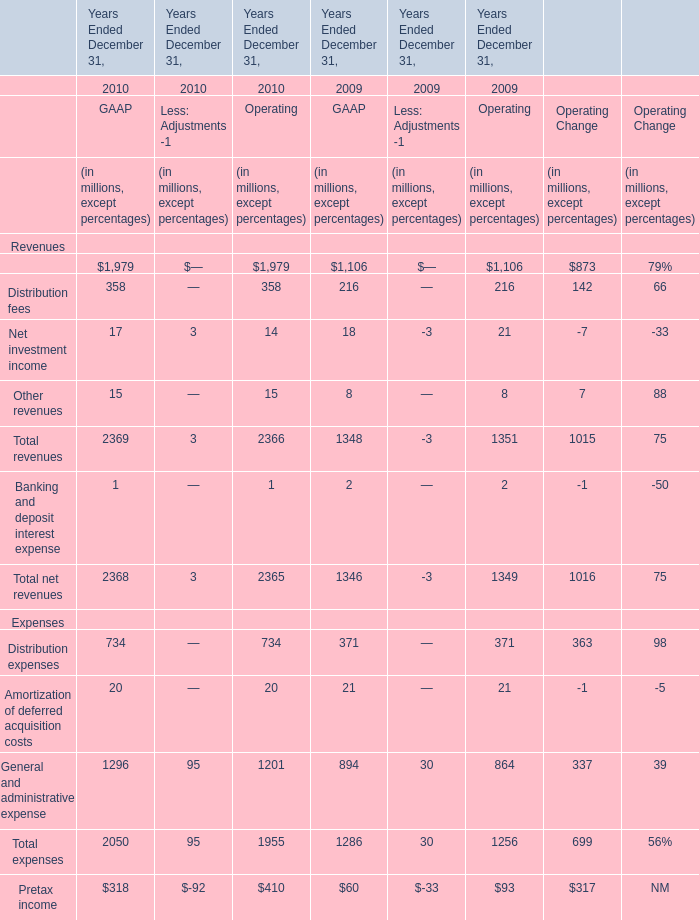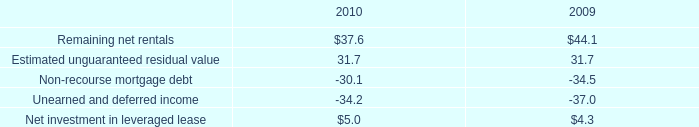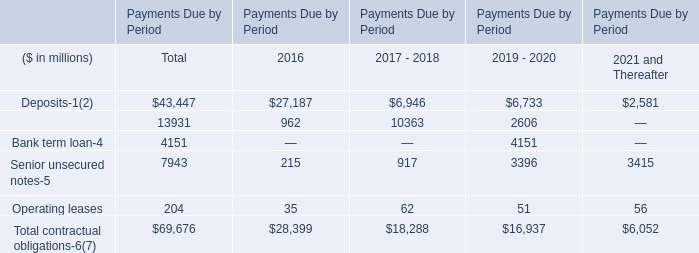What's the current increasing rate of total revenues of GAAP? 
Computations: ((2369 - 1348) / 1348)
Answer: 0.75742. 